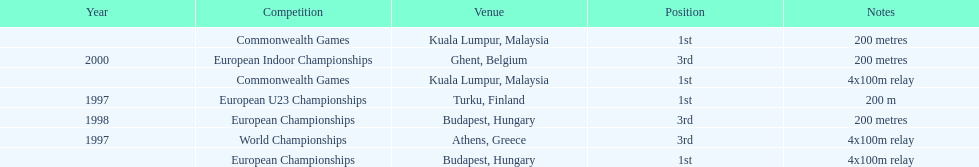In what year between 1997 and 2000 did julian golding, the sprinter representing the united kingdom and england finish first in both the 4 x 100 m relay and the 200 metres race? 1998. 